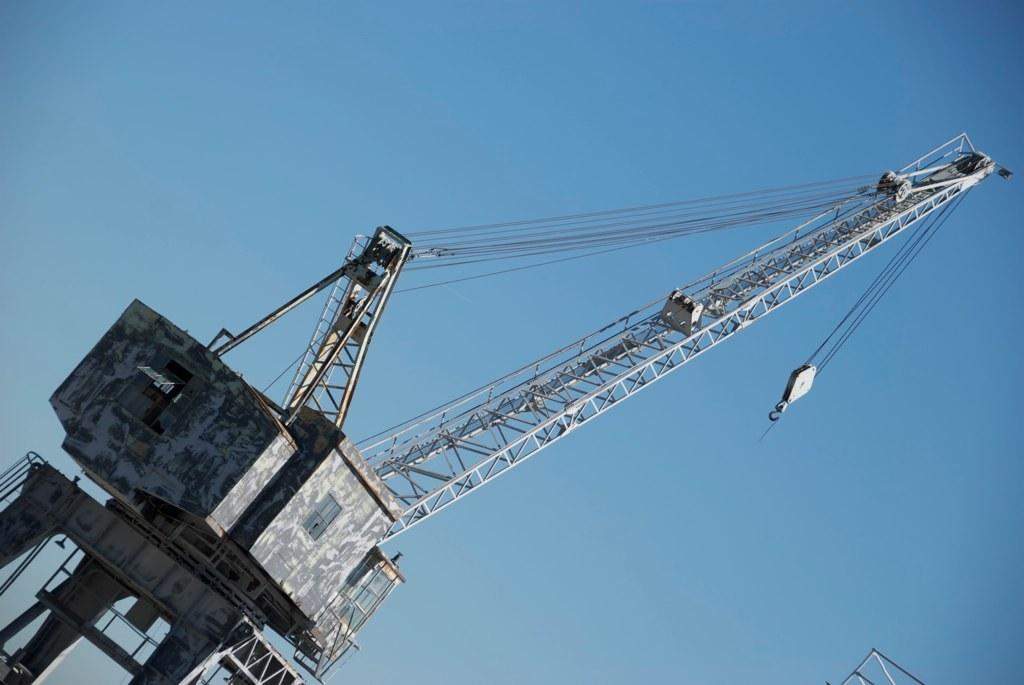What is the main subject of the image? The main subject of the image is a tall crane. Can you describe the appearance of the crane? The crane is tall and likely used for construction or lifting heavy objects. What type of watch is the crane wearing in the image? There is no watch present in the image, as the subject is a crane, which is an inanimate object and does not wear watches. 